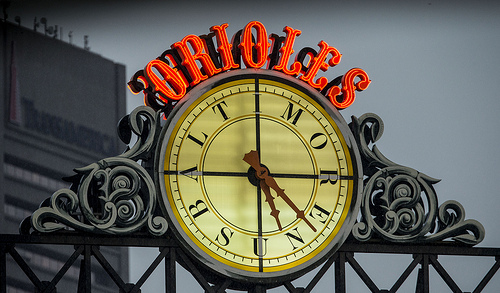Describe the style of the clock in the image. The clock features Roman numerals with ornate metalwork and is adorned with what appears to be a classic, yet elegant design suggesting a vintage or historical significance. 